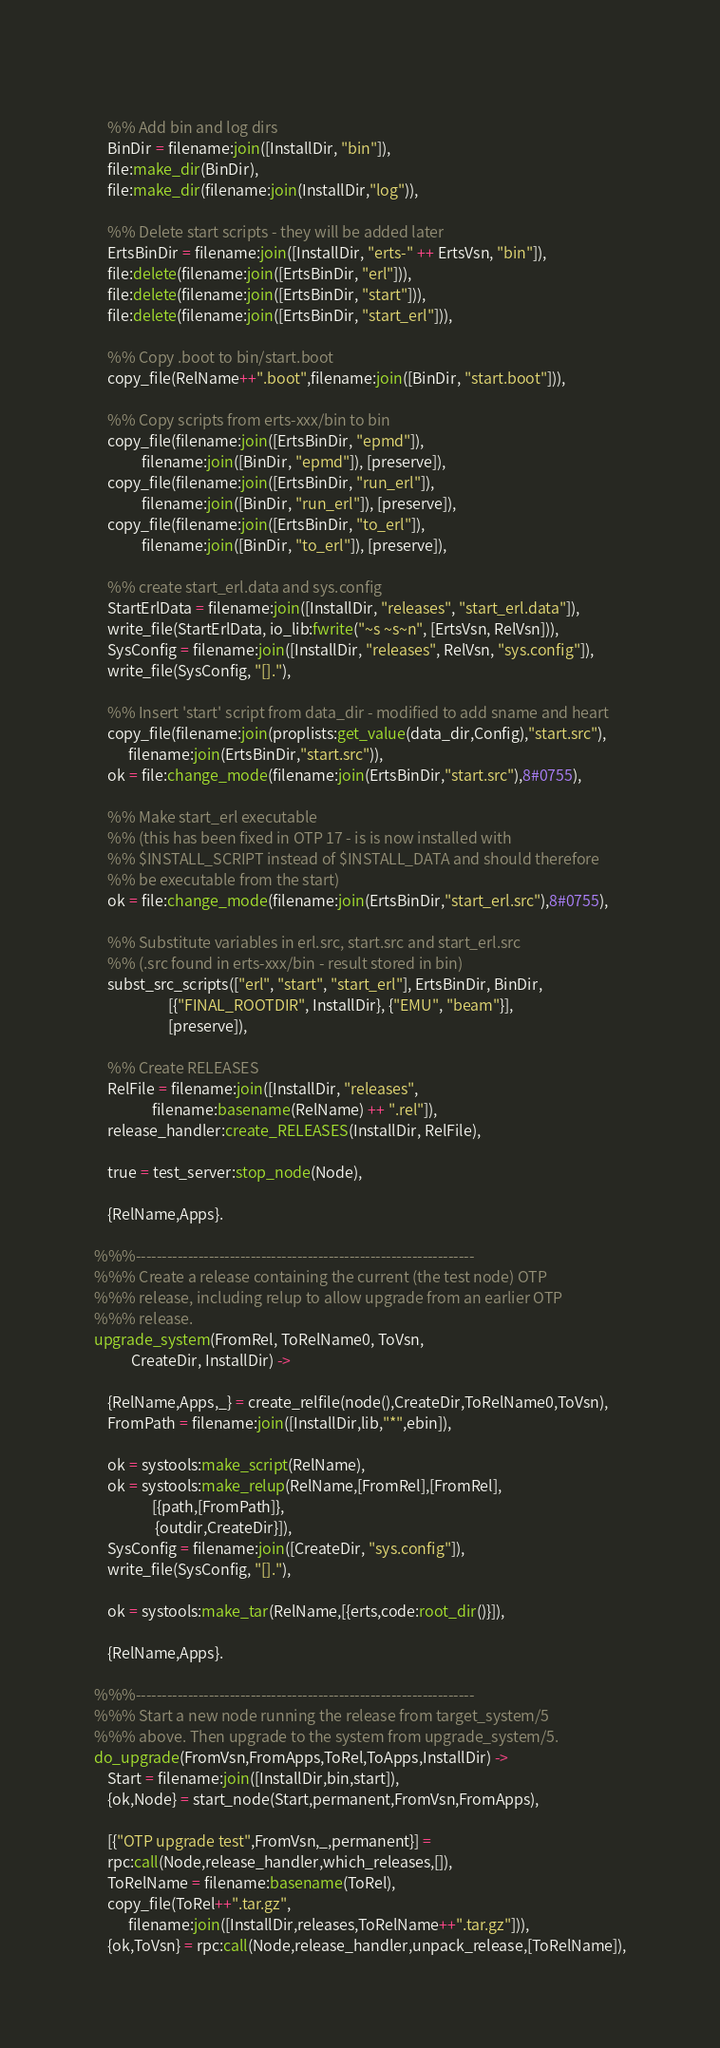Convert code to text. <code><loc_0><loc_0><loc_500><loc_500><_Erlang_>    
    %% Add bin and log dirs
    BinDir = filename:join([InstallDir, "bin"]),
    file:make_dir(BinDir),
    file:make_dir(filename:join(InstallDir,"log")),

    %% Delete start scripts - they will be added later
    ErtsBinDir = filename:join([InstallDir, "erts-" ++ ErtsVsn, "bin"]),
    file:delete(filename:join([ErtsBinDir, "erl"])),
    file:delete(filename:join([ErtsBinDir, "start"])),
    file:delete(filename:join([ErtsBinDir, "start_erl"])),
    
    %% Copy .boot to bin/start.boot
    copy_file(RelName++".boot",filename:join([BinDir, "start.boot"])),
    
    %% Copy scripts from erts-xxx/bin to bin
    copy_file(filename:join([ErtsBinDir, "epmd"]), 
              filename:join([BinDir, "epmd"]), [preserve]),
    copy_file(filename:join([ErtsBinDir, "run_erl"]), 
              filename:join([BinDir, "run_erl"]), [preserve]),
    copy_file(filename:join([ErtsBinDir, "to_erl"]), 
              filename:join([BinDir, "to_erl"]), [preserve]),
    
    %% create start_erl.data and sys.config
    StartErlData = filename:join([InstallDir, "releases", "start_erl.data"]),
    write_file(StartErlData, io_lib:fwrite("~s ~s~n", [ErtsVsn, RelVsn])),
    SysConfig = filename:join([InstallDir, "releases", RelVsn, "sys.config"]),
    write_file(SysConfig, "[]."),
    
    %% Insert 'start' script from data_dir - modified to add sname and heart
    copy_file(filename:join(proplists:get_value(data_dir,Config),"start.src"),
	      filename:join(ErtsBinDir,"start.src")),
    ok = file:change_mode(filename:join(ErtsBinDir,"start.src"),8#0755),

    %% Make start_erl executable
    %% (this has been fixed in OTP 17 - is is now installed with
    %% $INSTALL_SCRIPT instead of $INSTALL_DATA and should therefore
    %% be executable from the start)
    ok = file:change_mode(filename:join(ErtsBinDir,"start_erl.src"),8#0755),

    %% Substitute variables in erl.src, start.src and start_erl.src
    %% (.src found in erts-xxx/bin - result stored in bin)
    subst_src_scripts(["erl", "start", "start_erl"], ErtsBinDir, BinDir, 
                      [{"FINAL_ROOTDIR", InstallDir}, {"EMU", "beam"}],
                      [preserve]),

    %% Create RELEASES
    RelFile = filename:join([InstallDir, "releases", 
			     filename:basename(RelName) ++ ".rel"]),
    release_handler:create_RELEASES(InstallDir, RelFile),

    true = test_server:stop_node(Node),

    {RelName,Apps}.

%%%-----------------------------------------------------------------
%%% Create a release containing the current (the test node) OTP
%%% release, including relup to allow upgrade from an earlier OTP
%%% release.
upgrade_system(FromRel, ToRelName0, ToVsn,
	       CreateDir, InstallDir) ->

    {RelName,Apps,_} = create_relfile(node(),CreateDir,ToRelName0,ToVsn),
    FromPath = filename:join([InstallDir,lib,"*",ebin]),

    ok = systools:make_script(RelName),
    ok = systools:make_relup(RelName,[FromRel],[FromRel],
			     [{path,[FromPath]},
			      {outdir,CreateDir}]),
    SysConfig = filename:join([CreateDir, "sys.config"]),
    write_file(SysConfig, "[]."),

    ok = systools:make_tar(RelName,[{erts,code:root_dir()}]),

    {RelName,Apps}.

%%%-----------------------------------------------------------------
%%% Start a new node running the release from target_system/5
%%% above. Then upgrade to the system from upgrade_system/5.
do_upgrade(FromVsn,FromApps,ToRel,ToApps,InstallDir) ->
    Start = filename:join([InstallDir,bin,start]),
    {ok,Node} = start_node(Start,permanent,FromVsn,FromApps),

    [{"OTP upgrade test",FromVsn,_,permanent}] =
	rpc:call(Node,release_handler,which_releases,[]),
    ToRelName = filename:basename(ToRel),
    copy_file(ToRel++".tar.gz",
	      filename:join([InstallDir,releases,ToRelName++".tar.gz"])),
    {ok,ToVsn} = rpc:call(Node,release_handler,unpack_release,[ToRelName]),</code> 